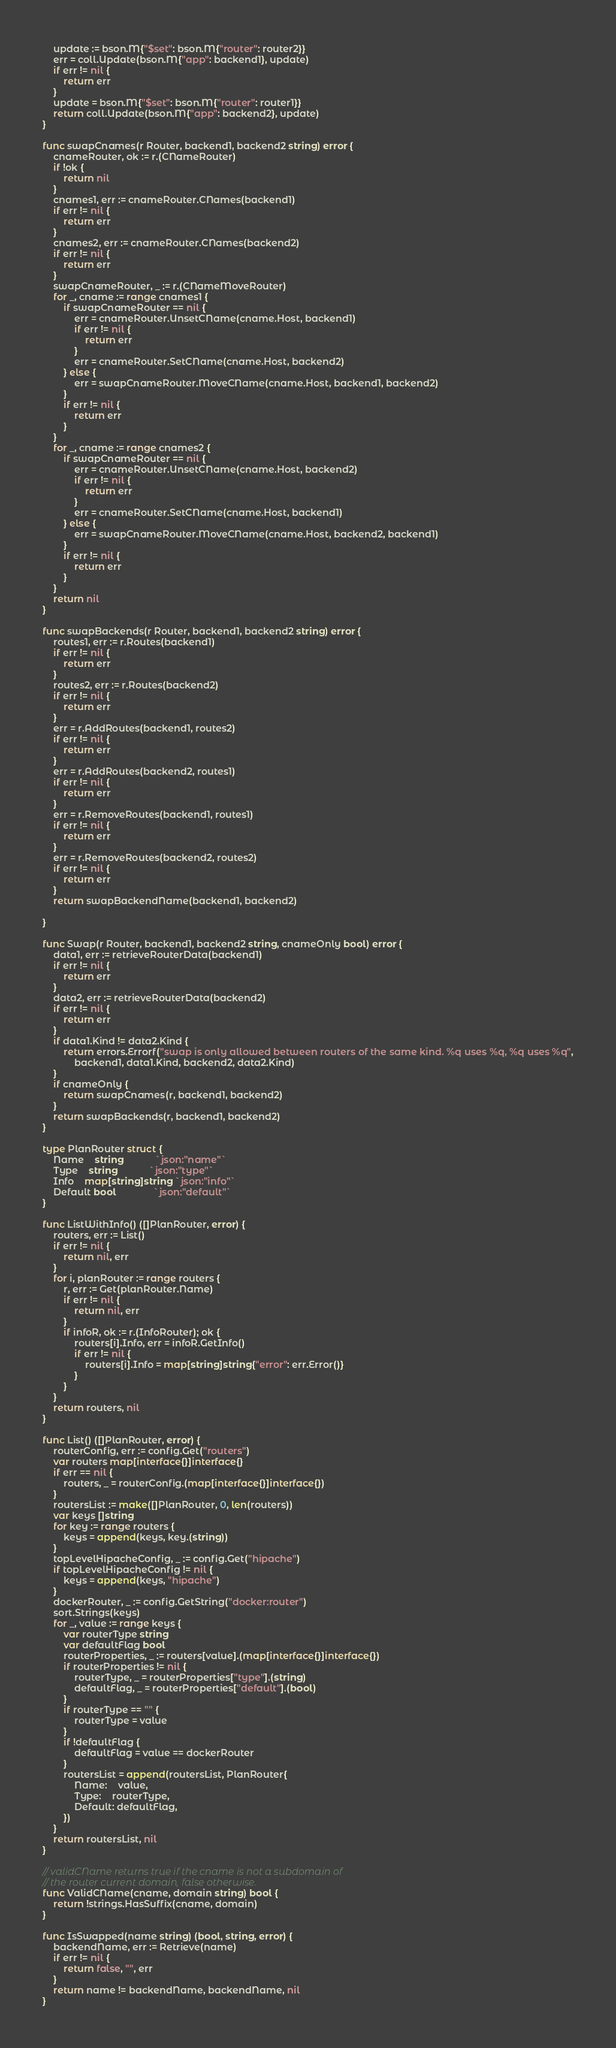Convert code to text. <code><loc_0><loc_0><loc_500><loc_500><_Go_>	update := bson.M{"$set": bson.M{"router": router2}}
	err = coll.Update(bson.M{"app": backend1}, update)
	if err != nil {
		return err
	}
	update = bson.M{"$set": bson.M{"router": router1}}
	return coll.Update(bson.M{"app": backend2}, update)
}

func swapCnames(r Router, backend1, backend2 string) error {
	cnameRouter, ok := r.(CNameRouter)
	if !ok {
		return nil
	}
	cnames1, err := cnameRouter.CNames(backend1)
	if err != nil {
		return err
	}
	cnames2, err := cnameRouter.CNames(backend2)
	if err != nil {
		return err
	}
	swapCnameRouter, _ := r.(CNameMoveRouter)
	for _, cname := range cnames1 {
		if swapCnameRouter == nil {
			err = cnameRouter.UnsetCName(cname.Host, backend1)
			if err != nil {
				return err
			}
			err = cnameRouter.SetCName(cname.Host, backend2)
		} else {
			err = swapCnameRouter.MoveCName(cname.Host, backend1, backend2)
		}
		if err != nil {
			return err
		}
	}
	for _, cname := range cnames2 {
		if swapCnameRouter == nil {
			err = cnameRouter.UnsetCName(cname.Host, backend2)
			if err != nil {
				return err
			}
			err = cnameRouter.SetCName(cname.Host, backend1)
		} else {
			err = swapCnameRouter.MoveCName(cname.Host, backend2, backend1)
		}
		if err != nil {
			return err
		}
	}
	return nil
}

func swapBackends(r Router, backend1, backend2 string) error {
	routes1, err := r.Routes(backend1)
	if err != nil {
		return err
	}
	routes2, err := r.Routes(backend2)
	if err != nil {
		return err
	}
	err = r.AddRoutes(backend1, routes2)
	if err != nil {
		return err
	}
	err = r.AddRoutes(backend2, routes1)
	if err != nil {
		return err
	}
	err = r.RemoveRoutes(backend1, routes1)
	if err != nil {
		return err
	}
	err = r.RemoveRoutes(backend2, routes2)
	if err != nil {
		return err
	}
	return swapBackendName(backend1, backend2)

}

func Swap(r Router, backend1, backend2 string, cnameOnly bool) error {
	data1, err := retrieveRouterData(backend1)
	if err != nil {
		return err
	}
	data2, err := retrieveRouterData(backend2)
	if err != nil {
		return err
	}
	if data1.Kind != data2.Kind {
		return errors.Errorf("swap is only allowed between routers of the same kind. %q uses %q, %q uses %q",
			backend1, data1.Kind, backend2, data2.Kind)
	}
	if cnameOnly {
		return swapCnames(r, backend1, backend2)
	}
	return swapBackends(r, backend1, backend2)
}

type PlanRouter struct {
	Name    string            `json:"name"`
	Type    string            `json:"type"`
	Info    map[string]string `json:"info"`
	Default bool              `json:"default"`
}

func ListWithInfo() ([]PlanRouter, error) {
	routers, err := List()
	if err != nil {
		return nil, err
	}
	for i, planRouter := range routers {
		r, err := Get(planRouter.Name)
		if err != nil {
			return nil, err
		}
		if infoR, ok := r.(InfoRouter); ok {
			routers[i].Info, err = infoR.GetInfo()
			if err != nil {
				routers[i].Info = map[string]string{"error": err.Error()}
			}
		}
	}
	return routers, nil
}

func List() ([]PlanRouter, error) {
	routerConfig, err := config.Get("routers")
	var routers map[interface{}]interface{}
	if err == nil {
		routers, _ = routerConfig.(map[interface{}]interface{})
	}
	routersList := make([]PlanRouter, 0, len(routers))
	var keys []string
	for key := range routers {
		keys = append(keys, key.(string))
	}
	topLevelHipacheConfig, _ := config.Get("hipache")
	if topLevelHipacheConfig != nil {
		keys = append(keys, "hipache")
	}
	dockerRouter, _ := config.GetString("docker:router")
	sort.Strings(keys)
	for _, value := range keys {
		var routerType string
		var defaultFlag bool
		routerProperties, _ := routers[value].(map[interface{}]interface{})
		if routerProperties != nil {
			routerType, _ = routerProperties["type"].(string)
			defaultFlag, _ = routerProperties["default"].(bool)
		}
		if routerType == "" {
			routerType = value
		}
		if !defaultFlag {
			defaultFlag = value == dockerRouter
		}
		routersList = append(routersList, PlanRouter{
			Name:    value,
			Type:    routerType,
			Default: defaultFlag,
		})
	}
	return routersList, nil
}

// validCName returns true if the cname is not a subdomain of
// the router current domain, false otherwise.
func ValidCName(cname, domain string) bool {
	return !strings.HasSuffix(cname, domain)
}

func IsSwapped(name string) (bool, string, error) {
	backendName, err := Retrieve(name)
	if err != nil {
		return false, "", err
	}
	return name != backendName, backendName, nil
}
</code> 